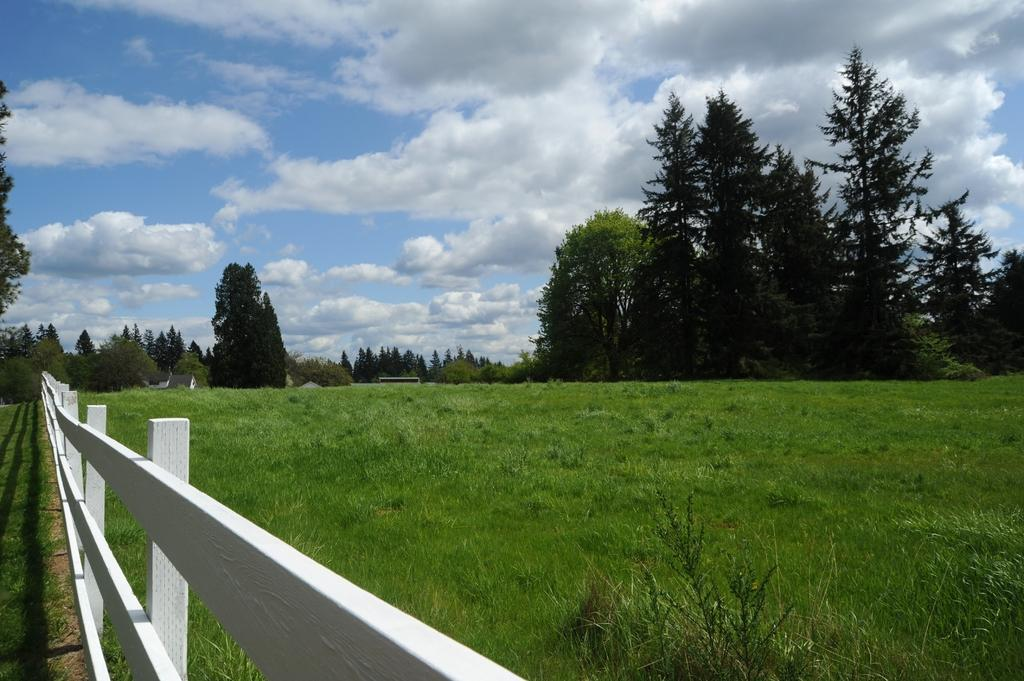What type of fencing is on the left side of the image? There is a wooden fencing on the left side of the image. What is covering the ground in the image? There is grass on the ground in the image. What can be seen in the background of the image? There are trees and the sky visible in the background of the image. What is the condition of the sky in the image? Clouds are present in the sky. What part of the city is depicted in the image? The image does not depict a specific part of the city, such as downtown. How is the grass in the image being controlled? There is no indication in the image that the grass is being controlled or managed in any way. 